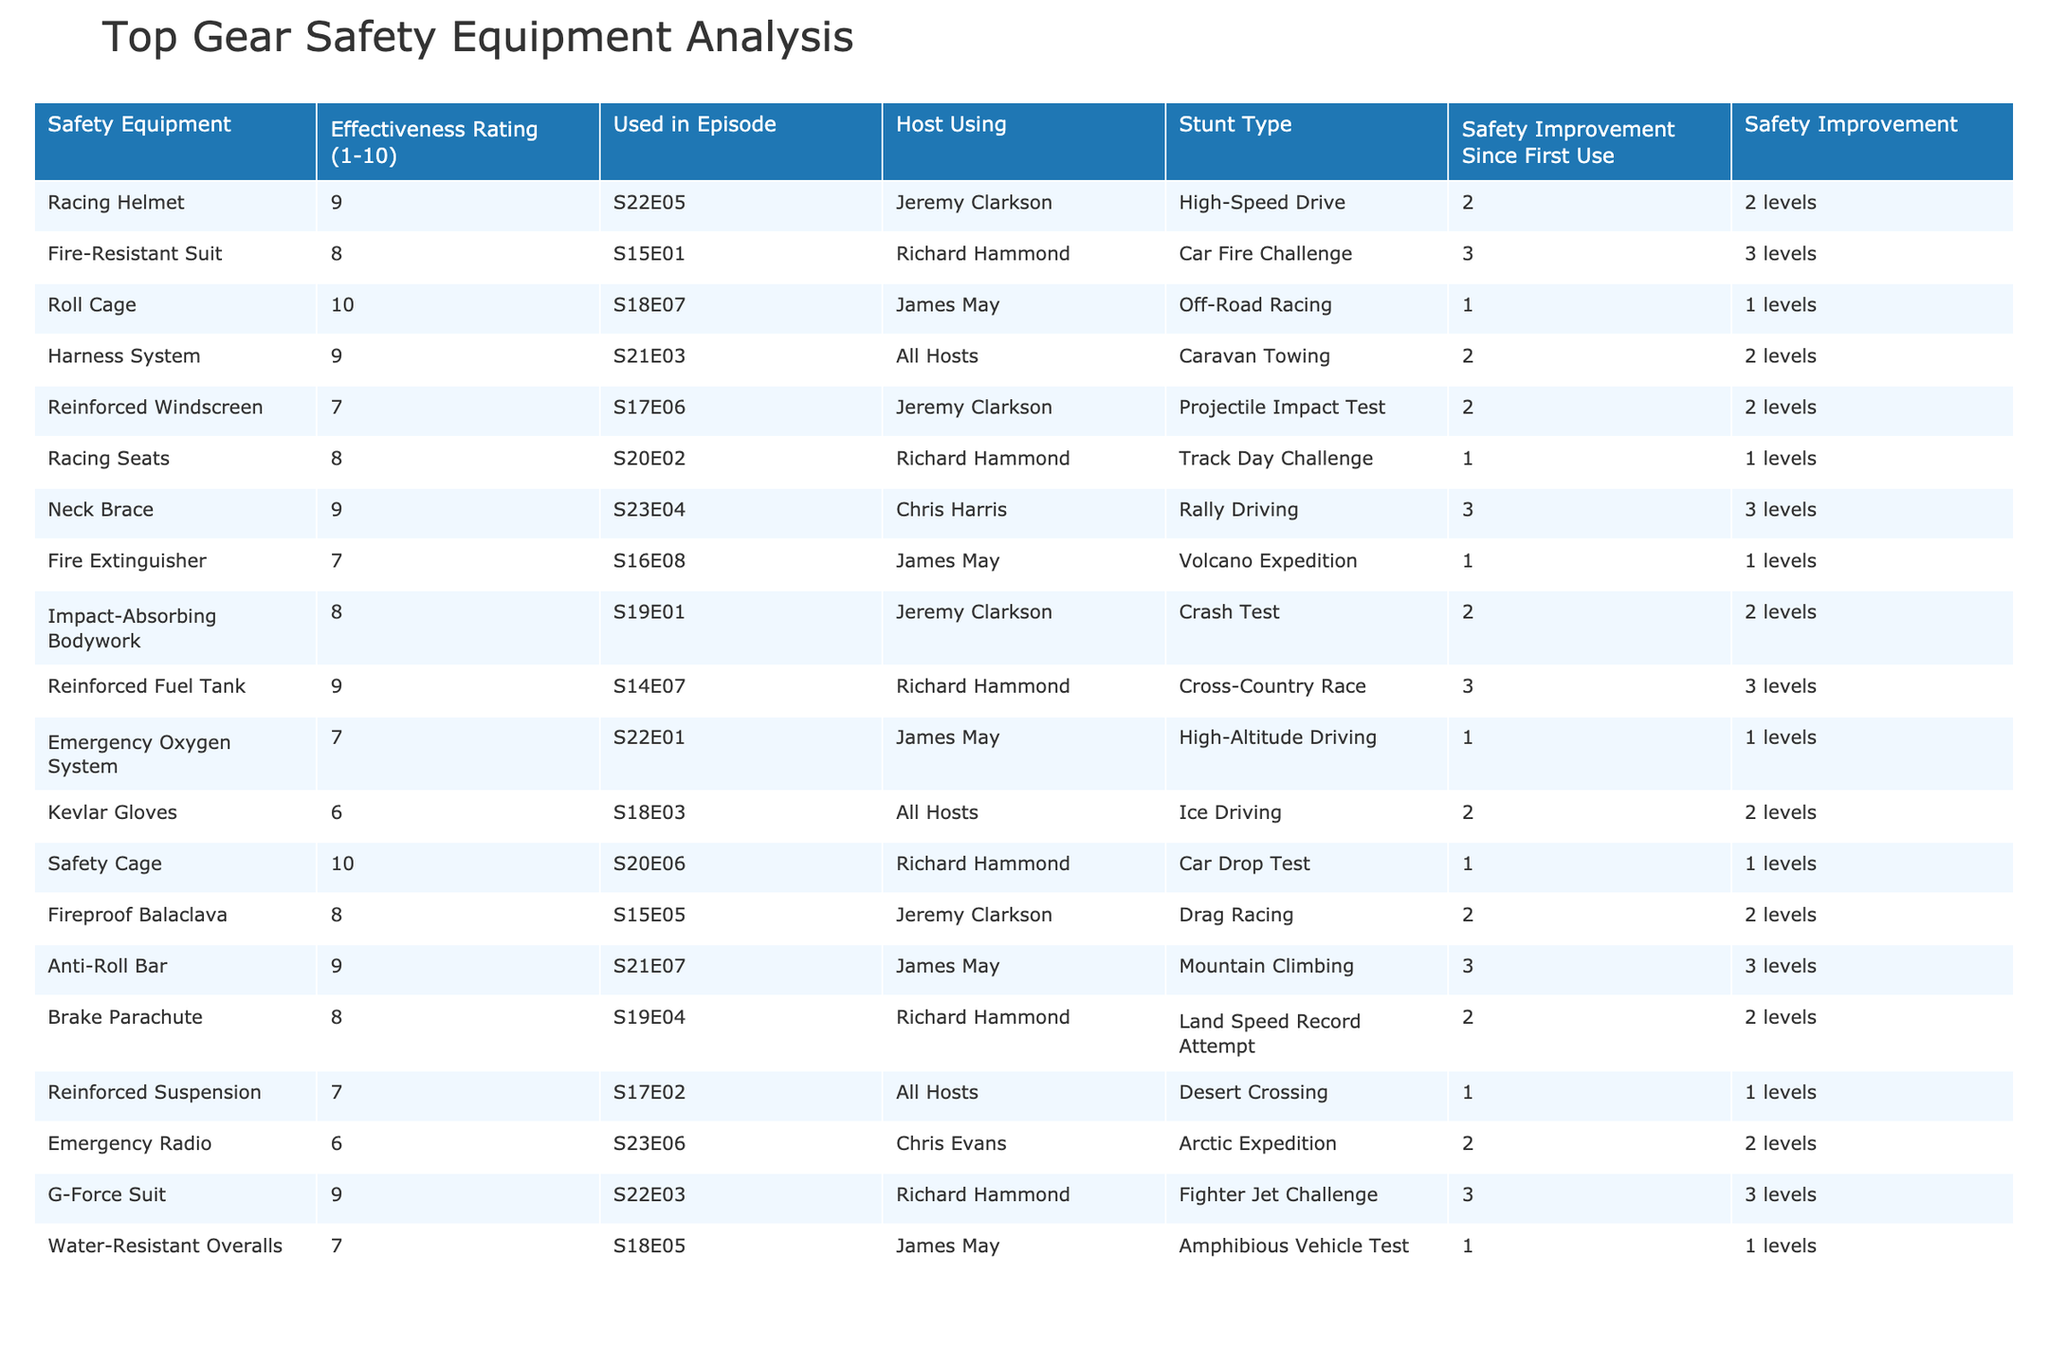What is the effectiveness rating of the Racing Helmet? The effectiveness rating of the Racing Helmet is listed in the table under the column "Effectiveness Rating (1-10)", which shows a rating of 9.
Answer: 9 Which host used the Fire-Resistant Suit? The “Used in Episode” column indicates that the Fire-Resistant Suit was used in S15E01, and the corresponding host listed is Richard Hammond.
Answer: Richard Hammond What is the highest effectiveness rating among the safety equipment? By checking the "Effectiveness Rating" column, the highest rating listed is 10, which corresponds to the Roll Cage and Safety Cage.
Answer: 10 Which stunt type had the lowest effectiveness rating? Looking through the "Effectiveness Rating" column for the lowest value, the G-Force Suit has a rating of 6, making it the lowest.
Answer: 6 How many safety equipment pieces have an effectiveness rating of 9? By counting all occurrences of the effectiveness rating of 9 in the table, there are 5 pieces of equipment that have this rating.
Answer: 5 Is the Harness System used by all hosts? The "Host Using" column shows "All Hosts" for the Harness System, confirming that it was indeed used by all hosts.
Answer: Yes What is the average effectiveness rating of all the equipment used? To find the average, add all the effectiveness ratings (9+8+10+9+7+8+9+7+8+9+7+6+9+8+9+7+6+9+7 = 150) and divide by the number of pieces (18), giving an average of 150/18 ≈ 8.33.
Answer: 8.33 What stunt did Chris Harris perform with a neck brace? The table indicates that Chris Harris used the neck brace in the stunt type Rally Driving, as noted in the corresponding columns.
Answer: Rally Driving Which safety equipment was used in the Volcano Expedition? The “Used in Episode” column shows that the Fire Extinguisher was utilized in the Volcano Expedition stunt, as referenced in the "Stunt Type" column.
Answer: Fire Extinguisher Has the effectiveness rating of Reinforced Fuel Tank improved since its first use? The table shows that the Reinforced Fuel Tank has a safety improvement rating of 3 levels since its first use, indicating an improvement.
Answer: Yes 